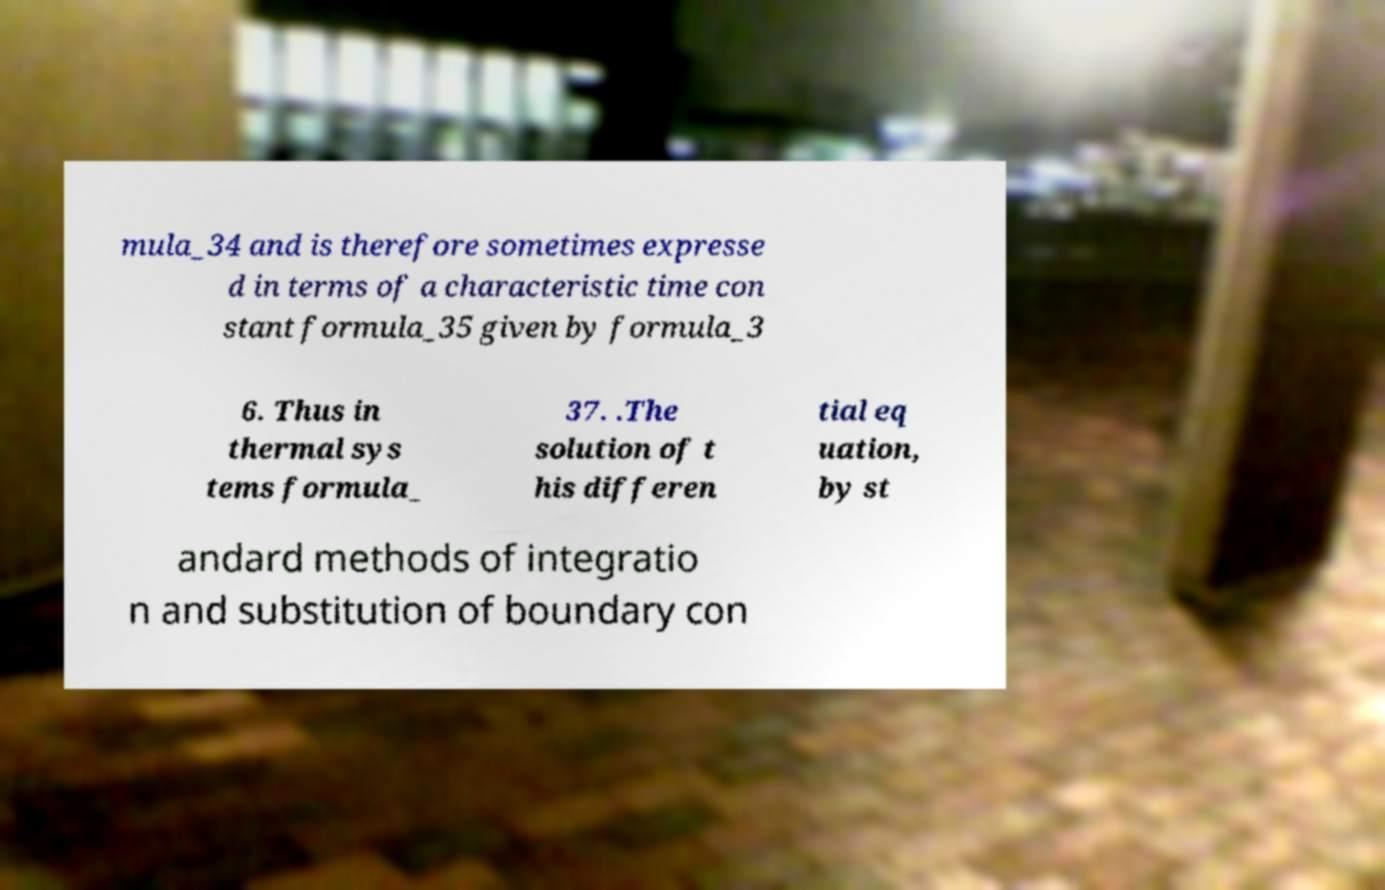For documentation purposes, I need the text within this image transcribed. Could you provide that? mula_34 and is therefore sometimes expresse d in terms of a characteristic time con stant formula_35 given by formula_3 6. Thus in thermal sys tems formula_ 37. .The solution of t his differen tial eq uation, by st andard methods of integratio n and substitution of boundary con 